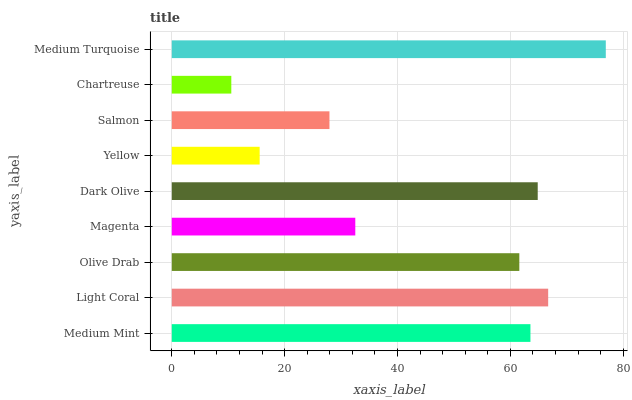Is Chartreuse the minimum?
Answer yes or no. Yes. Is Medium Turquoise the maximum?
Answer yes or no. Yes. Is Light Coral the minimum?
Answer yes or no. No. Is Light Coral the maximum?
Answer yes or no. No. Is Light Coral greater than Medium Mint?
Answer yes or no. Yes. Is Medium Mint less than Light Coral?
Answer yes or no. Yes. Is Medium Mint greater than Light Coral?
Answer yes or no. No. Is Light Coral less than Medium Mint?
Answer yes or no. No. Is Olive Drab the high median?
Answer yes or no. Yes. Is Olive Drab the low median?
Answer yes or no. Yes. Is Medium Mint the high median?
Answer yes or no. No. Is Medium Mint the low median?
Answer yes or no. No. 